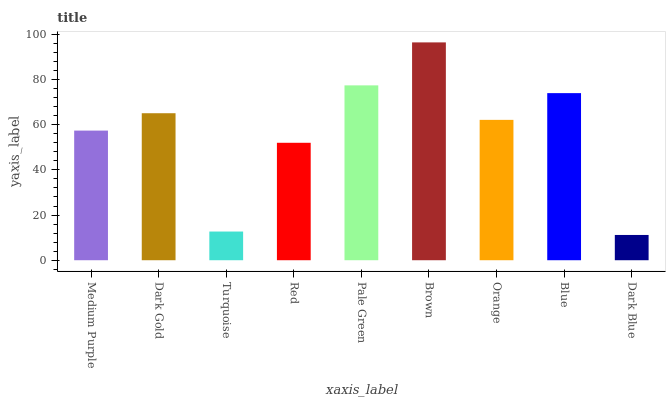Is Dark Blue the minimum?
Answer yes or no. Yes. Is Brown the maximum?
Answer yes or no. Yes. Is Dark Gold the minimum?
Answer yes or no. No. Is Dark Gold the maximum?
Answer yes or no. No. Is Dark Gold greater than Medium Purple?
Answer yes or no. Yes. Is Medium Purple less than Dark Gold?
Answer yes or no. Yes. Is Medium Purple greater than Dark Gold?
Answer yes or no. No. Is Dark Gold less than Medium Purple?
Answer yes or no. No. Is Orange the high median?
Answer yes or no. Yes. Is Orange the low median?
Answer yes or no. Yes. Is Pale Green the high median?
Answer yes or no. No. Is Medium Purple the low median?
Answer yes or no. No. 